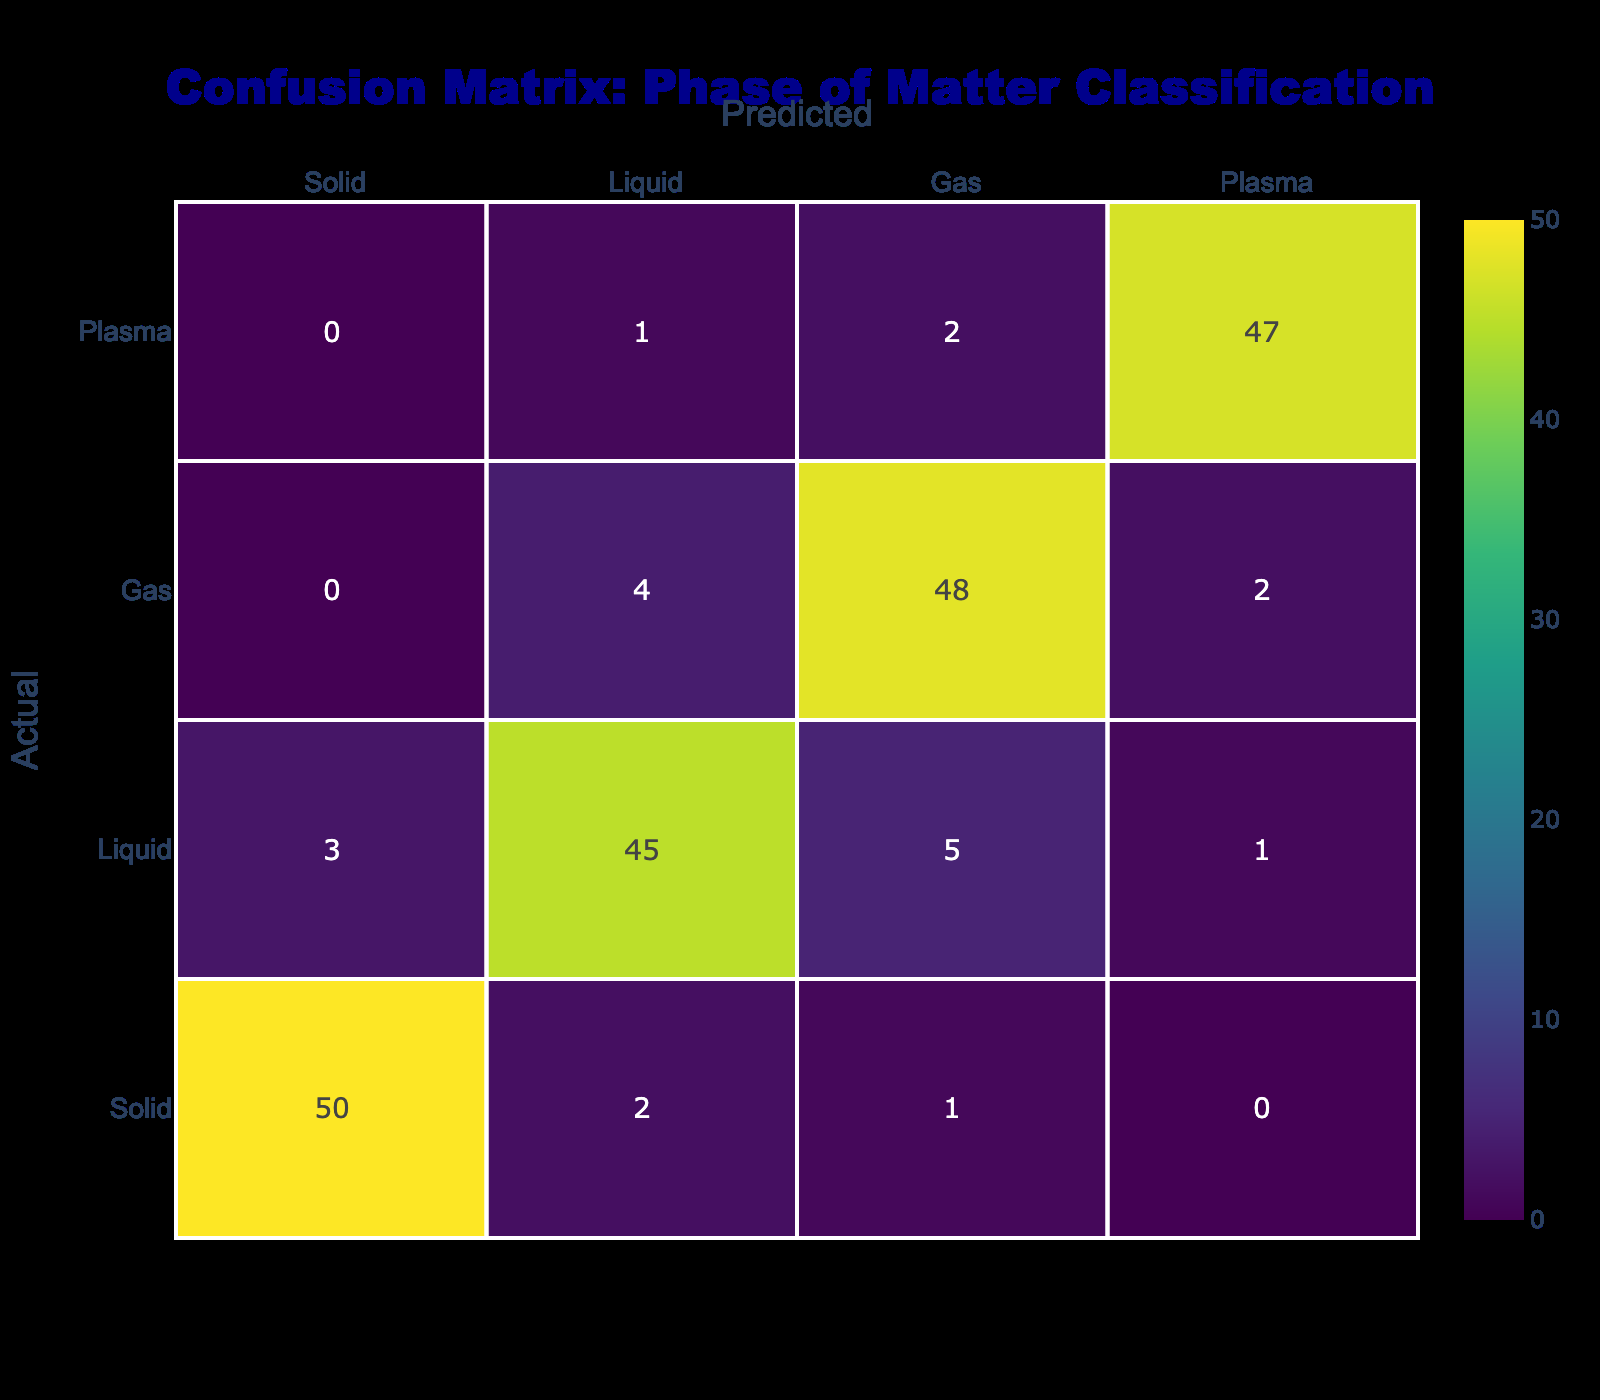What is the number of samples accurately predicted as Solid? From the table, the value in the "Solid" row and "Solid" column is 50. This indicates that 50 samples were correctly identified as Solid.
Answer: 50 What is the total number of samples misclassified as Liquid? To find the samples misclassified as Liquid, we look at the "Liquid" row and sum the values in the Solid, Gas, and Plasma columns: 3 (Solid) + 5 (Gas) + 1 (Plasma) = 9.
Answer: 9 Is there any sample incorrectly predicted as Gas when the actual phase was Plasma? The table shows that the entry for "Plasma" row and "Gas" column is 2. This indicates that 2 samples were misclassified as Gas when they were actually Plasma. Therefore, the answer is yes.
Answer: Yes What is the total number of predicted Gas samples? To find the total predicted as Gas, we sum the values in the Gas column for all actual phases: 1 (Solid) + 5 (Liquid) + 48 (Gas) + 2 (Plasma) = 56.
Answer: 56 What percentage of actual Plasma samples were correctly classified? The number of correctly classified Plasma samples is 47 (indicated in the "Plasma" row and "Plasma" column). The total actual Plasma samples, considering all predictions, is 47 + 1 + 2 + 0 = 50 (the total of the "Plasma" row). Therefore, the percentage is (47/50) * 100 = 94%.
Answer: 94% What is the difference between the number of samples predicted as Liquid and the number predicted as Gas? Looking at the table, the total samples predicted as Liquid is 45 + 3 + 5 + 1 = 54, and for Gas is 48 + 4 + 0 + 2 = 54. The difference is 54 - 54 = 0.
Answer: 0 Is the classification accuracy higher for Solid samples compared to Liquid samples? The accuracy can be calculated by comparing correctly classified samples for each phase. For Solid, accuracy is 50/(50+2+1+0) = 50/53 ≈ 0.943. For Liquid, it's 45/(3+45+5+1) = 45/54 ≈ 0.833. Since 0.943 > 0.833, the classification for Solid is indeed higher than for Liquid.
Answer: Yes How many total samples were predicted as Liquid? To find the total predicted as Liquid, we sum the values in the Liquid column across all actual phases: 2 (Solid) + 45 (Liquid) + 4 (Gas) + 1 (Plasma) = 52.
Answer: 52 What is the average number of misclassified samples across all phases of matter? We add the misclassifications for each actual phase: (2 for Solid) + (3 for Gas) + (4 for Liquid) + (1 for Plasma) = 10. Then we divide by the number of phases (4). Thus, the average is 10/4 = 2.5.
Answer: 2.5 